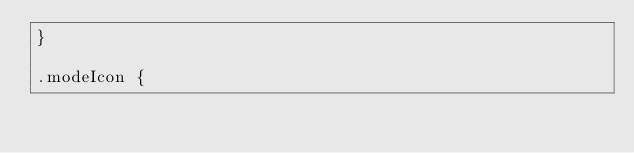<code> <loc_0><loc_0><loc_500><loc_500><_CSS_>}

.modeIcon {</code> 